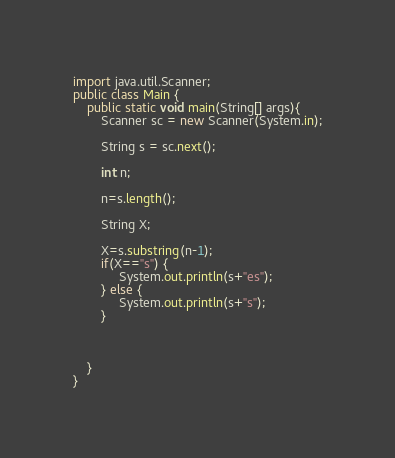<code> <loc_0><loc_0><loc_500><loc_500><_Java_>import java.util.Scanner;
public class Main {
    public static void main(String[] args){
        Scanner sc = new Scanner(System.in);

        String s = sc.next();

        int n;
        
        n=s.length();
        
        String X;
        
        X=s.substring(n-1);
        if(X=="s") {
        	 System.out.println(s+"es");
        } else {
        	 System.out.println(s+"s");
        }
        
    
       
    }
}

</code> 